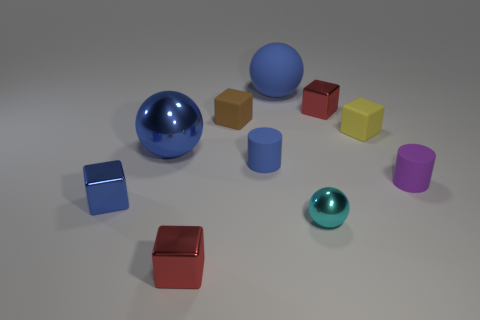Subtract all tiny red metal blocks. How many blocks are left? 3 Subtract all blue cylinders. How many cylinders are left? 1 Subtract all cylinders. How many objects are left? 8 Subtract all red cubes. Subtract all green cylinders. How many cubes are left? 3 Subtract all cyan blocks. How many green spheres are left? 0 Subtract all small shiny things. Subtract all small cubes. How many objects are left? 1 Add 6 small yellow things. How many small yellow things are left? 7 Add 1 big purple spheres. How many big purple spheres exist? 1 Subtract 1 blue cylinders. How many objects are left? 9 Subtract 1 cubes. How many cubes are left? 4 